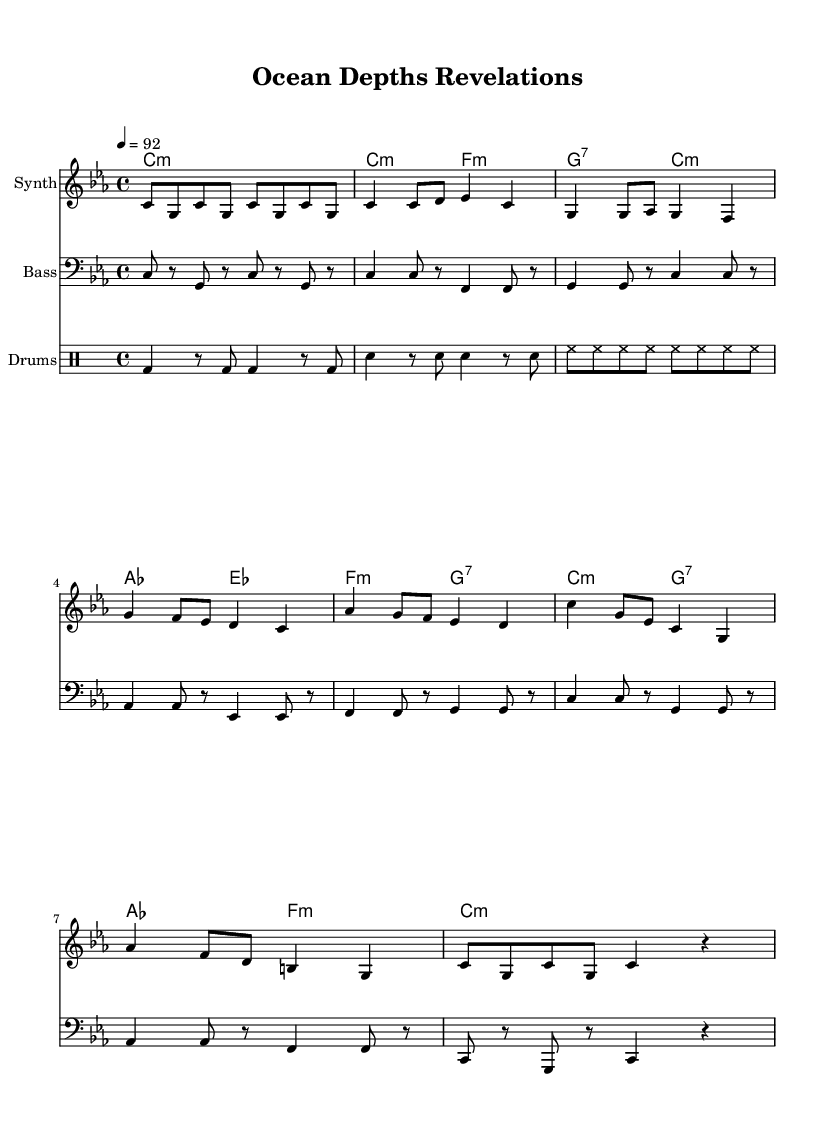What is the key signature of this music? The key signature is C minor, indicated by the presence of three flats. C minor is a parallel key to E flat major, and the flats are evident in the beginning of the sheet music.
Answer: C minor What is the time signature of this music? The time signature is 4/4, which means there are four beats per measure. This is indicated at the beginning of the score and is common in many musical genres, including rap.
Answer: 4/4 What is the tempo marking of the song? The tempo marking is 92 beats per minute, indicated at the start of the music. This sets the speed at which the piece should be performed, which is suitable for a relaxed rap flow.
Answer: 92 How many measures are in the chorus section? The chorus section consists of two measures, which can be identified by the repeated musical phrasing and structure in the sheet music.
Answer: 2 What instrument is indicated for the main melody? The main melody is indicated for a "Synth," which shows that synthesizers play a significant role in the sound of this rap piece. The instrument name appears at the top of the staff for this part.
Answer: Synth How many different sections are there in this piece? The piece contains four distinct sections: Intro, Verse, Chorus, and Bridge. These sections are labeled by different patterns in the music which provide structure to the rap.
Answer: 4 In which section does the bassline play a sustained note? The bassline plays a sustained note during the Outro section, where a longer note is held to provide a concluding sound. You can notice fewer notes in that segment compared to other parts.
Answer: Outro 